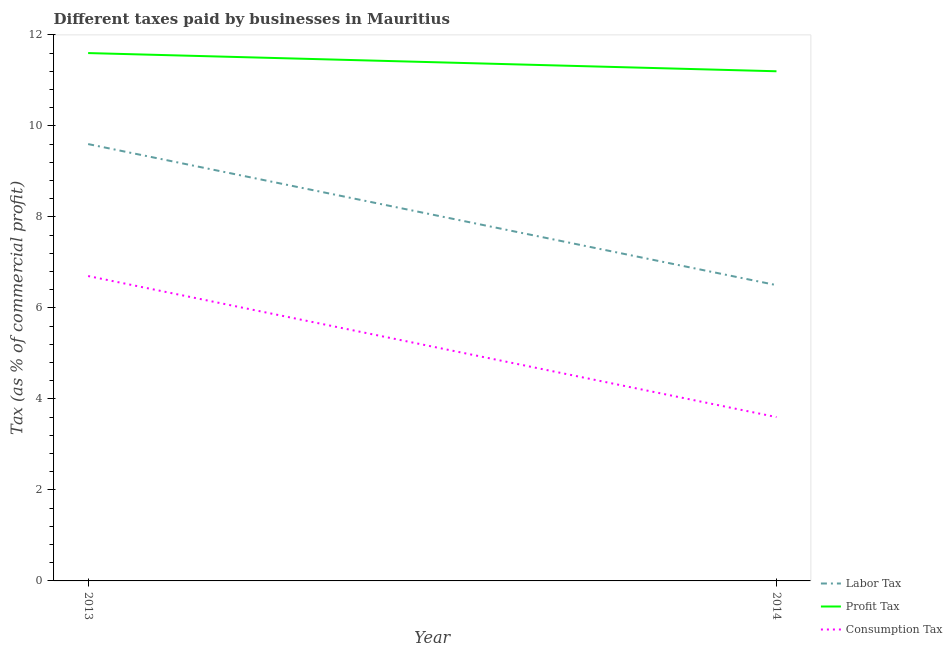How many different coloured lines are there?
Your response must be concise. 3. Does the line corresponding to percentage of labor tax intersect with the line corresponding to percentage of consumption tax?
Make the answer very short. No. Across all years, what is the minimum percentage of labor tax?
Provide a succinct answer. 6.5. What is the total percentage of labor tax in the graph?
Your answer should be compact. 16.1. What is the difference between the percentage of consumption tax in 2013 and the percentage of labor tax in 2014?
Give a very brief answer. 0.2. What is the average percentage of profit tax per year?
Your answer should be very brief. 11.4. In how many years, is the percentage of profit tax greater than 9.6 %?
Offer a very short reply. 2. What is the ratio of the percentage of profit tax in 2013 to that in 2014?
Keep it short and to the point. 1.04. Is the percentage of labor tax in 2013 less than that in 2014?
Your answer should be compact. No. Is it the case that in every year, the sum of the percentage of labor tax and percentage of profit tax is greater than the percentage of consumption tax?
Give a very brief answer. Yes. Is the percentage of profit tax strictly greater than the percentage of labor tax over the years?
Your answer should be very brief. Yes. How many lines are there?
Offer a terse response. 3. What is the difference between two consecutive major ticks on the Y-axis?
Provide a succinct answer. 2. Does the graph contain grids?
Offer a terse response. No. Where does the legend appear in the graph?
Offer a very short reply. Bottom right. How many legend labels are there?
Ensure brevity in your answer.  3. What is the title of the graph?
Your response must be concise. Different taxes paid by businesses in Mauritius. Does "Tertiary" appear as one of the legend labels in the graph?
Offer a very short reply. No. What is the label or title of the Y-axis?
Your answer should be compact. Tax (as % of commercial profit). What is the Tax (as % of commercial profit) in Labor Tax in 2013?
Provide a short and direct response. 9.6. What is the Tax (as % of commercial profit) of Consumption Tax in 2013?
Your answer should be compact. 6.7. What is the Tax (as % of commercial profit) of Labor Tax in 2014?
Offer a terse response. 6.5. What is the Tax (as % of commercial profit) in Profit Tax in 2014?
Give a very brief answer. 11.2. What is the Tax (as % of commercial profit) in Consumption Tax in 2014?
Your answer should be compact. 3.6. Across all years, what is the maximum Tax (as % of commercial profit) in Profit Tax?
Your answer should be compact. 11.6. Across all years, what is the maximum Tax (as % of commercial profit) of Consumption Tax?
Ensure brevity in your answer.  6.7. Across all years, what is the minimum Tax (as % of commercial profit) of Profit Tax?
Your answer should be compact. 11.2. What is the total Tax (as % of commercial profit) in Labor Tax in the graph?
Make the answer very short. 16.1. What is the total Tax (as % of commercial profit) in Profit Tax in the graph?
Make the answer very short. 22.8. What is the total Tax (as % of commercial profit) in Consumption Tax in the graph?
Your response must be concise. 10.3. What is the difference between the Tax (as % of commercial profit) of Profit Tax in 2013 and the Tax (as % of commercial profit) of Consumption Tax in 2014?
Make the answer very short. 8. What is the average Tax (as % of commercial profit) in Labor Tax per year?
Offer a terse response. 8.05. What is the average Tax (as % of commercial profit) in Consumption Tax per year?
Provide a succinct answer. 5.15. What is the ratio of the Tax (as % of commercial profit) of Labor Tax in 2013 to that in 2014?
Make the answer very short. 1.48. What is the ratio of the Tax (as % of commercial profit) of Profit Tax in 2013 to that in 2014?
Ensure brevity in your answer.  1.04. What is the ratio of the Tax (as % of commercial profit) in Consumption Tax in 2013 to that in 2014?
Keep it short and to the point. 1.86. What is the difference between the highest and the second highest Tax (as % of commercial profit) in Labor Tax?
Offer a very short reply. 3.1. What is the difference between the highest and the second highest Tax (as % of commercial profit) in Profit Tax?
Make the answer very short. 0.4. 